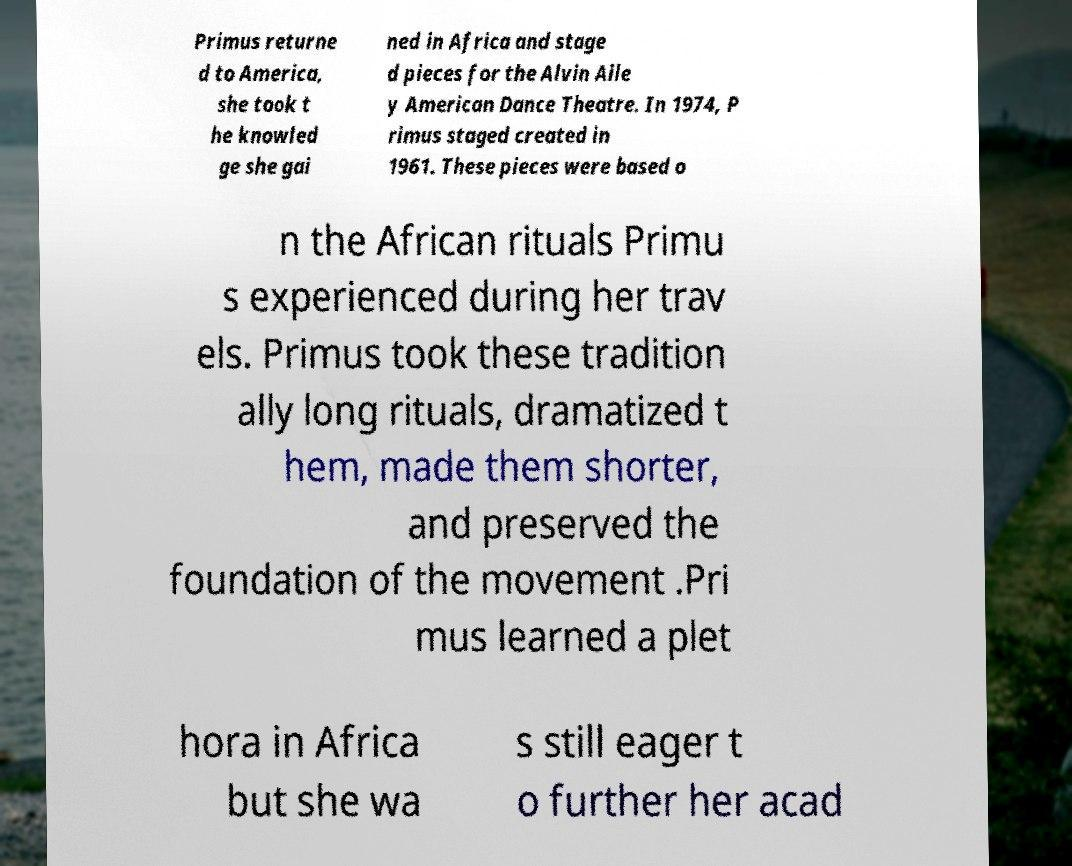Could you assist in decoding the text presented in this image and type it out clearly? Primus returne d to America, she took t he knowled ge she gai ned in Africa and stage d pieces for the Alvin Aile y American Dance Theatre. In 1974, P rimus staged created in 1961. These pieces were based o n the African rituals Primu s experienced during her trav els. Primus took these tradition ally long rituals, dramatized t hem, made them shorter, and preserved the foundation of the movement .Pri mus learned a plet hora in Africa but she wa s still eager t o further her acad 